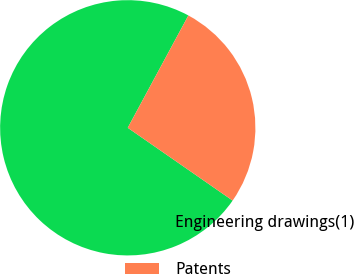<chart> <loc_0><loc_0><loc_500><loc_500><pie_chart><fcel>Engineering drawings(1)<fcel>Patents<nl><fcel>73.22%<fcel>26.78%<nl></chart> 